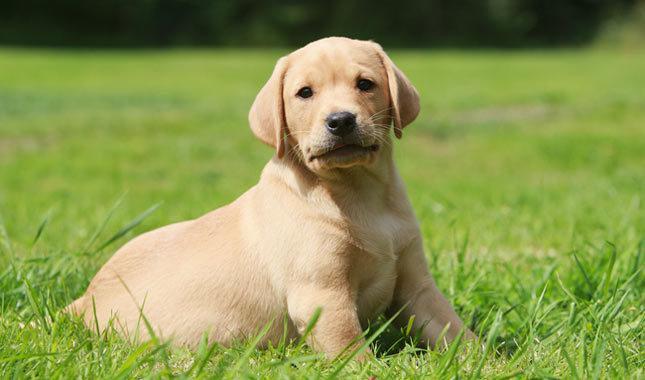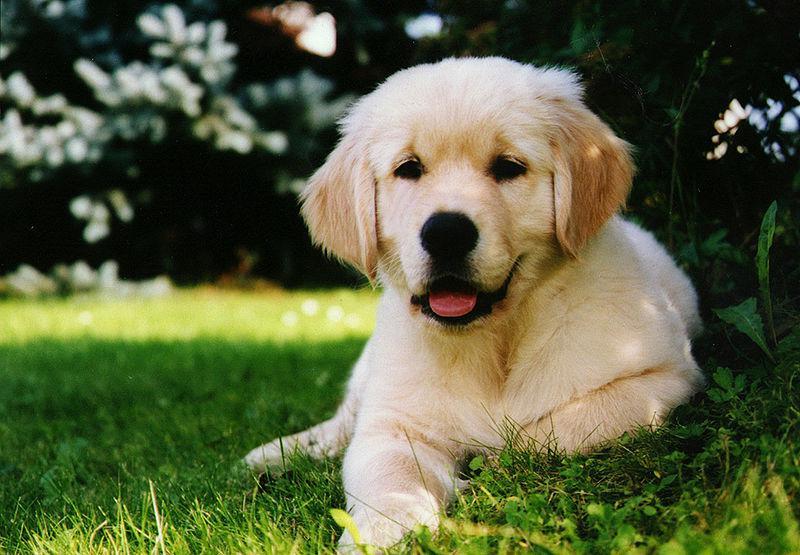The first image is the image on the left, the second image is the image on the right. For the images displayed, is the sentence "There are exactly two dogs in the left image." factually correct? Answer yes or no. No. 